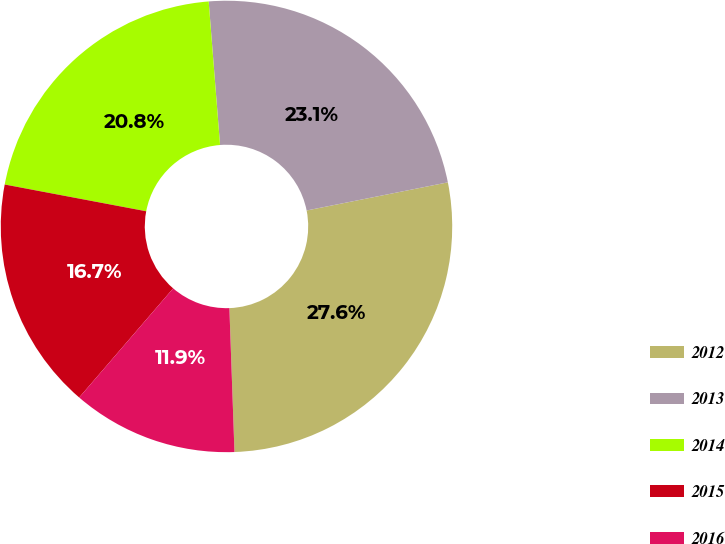<chart> <loc_0><loc_0><loc_500><loc_500><pie_chart><fcel>2012<fcel>2013<fcel>2014<fcel>2015<fcel>2016<nl><fcel>27.57%<fcel>23.13%<fcel>20.77%<fcel>16.66%<fcel>11.88%<nl></chart> 